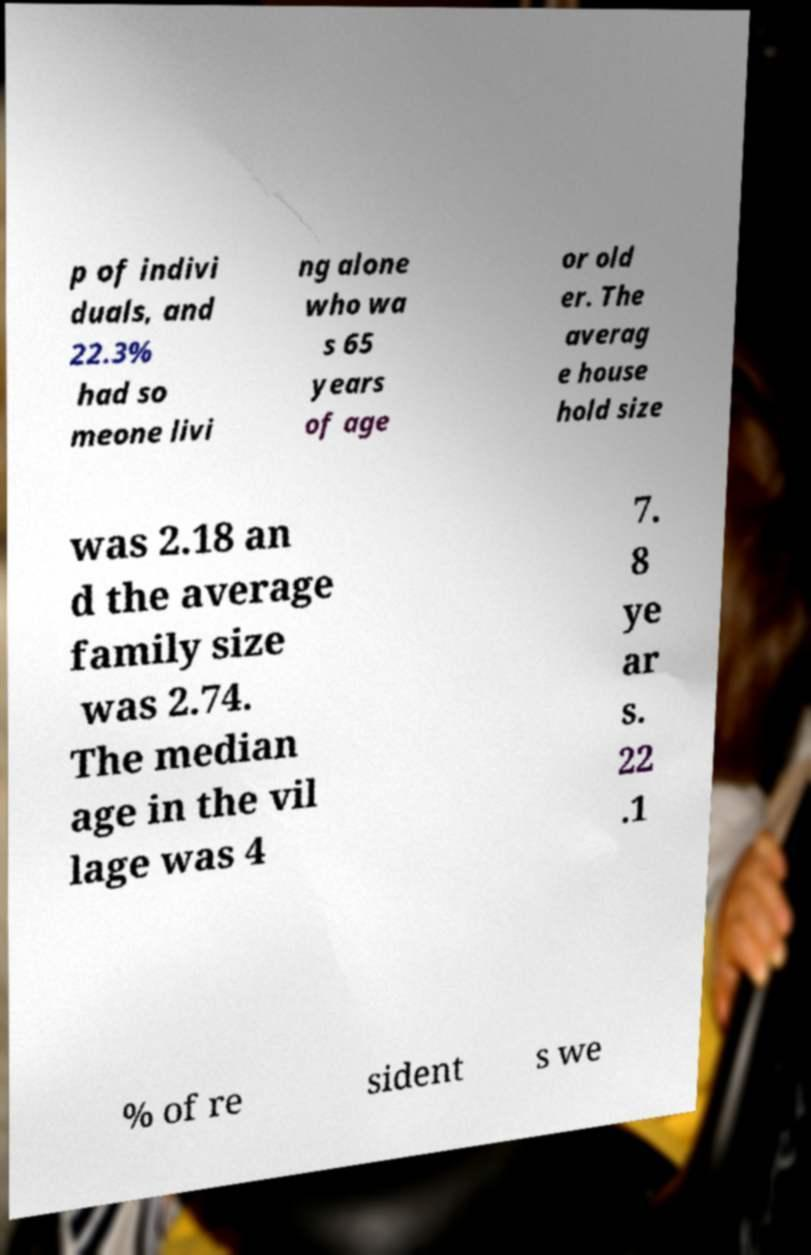Could you assist in decoding the text presented in this image and type it out clearly? p of indivi duals, and 22.3% had so meone livi ng alone who wa s 65 years of age or old er. The averag e house hold size was 2.18 an d the average family size was 2.74. The median age in the vil lage was 4 7. 8 ye ar s. 22 .1 % of re sident s we 